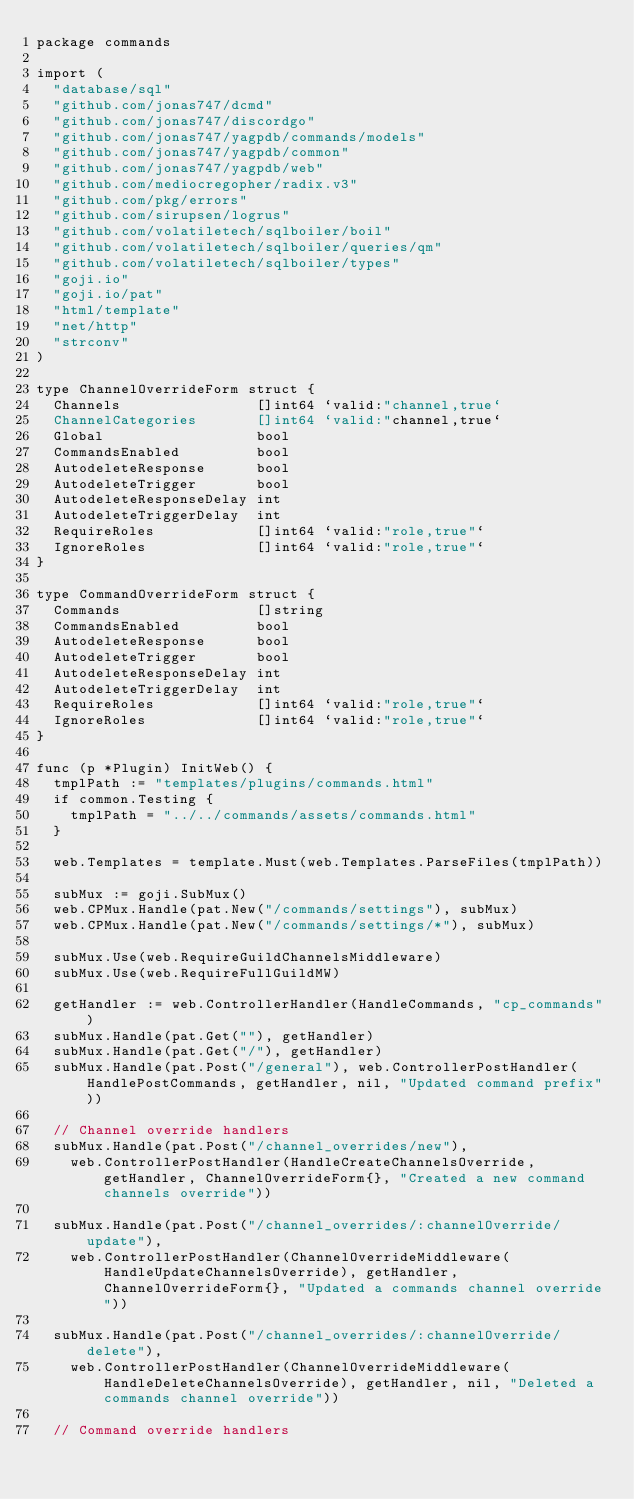Convert code to text. <code><loc_0><loc_0><loc_500><loc_500><_Go_>package commands

import (
	"database/sql"
	"github.com/jonas747/dcmd"
	"github.com/jonas747/discordgo"
	"github.com/jonas747/yagpdb/commands/models"
	"github.com/jonas747/yagpdb/common"
	"github.com/jonas747/yagpdb/web"
	"github.com/mediocregopher/radix.v3"
	"github.com/pkg/errors"
	"github.com/sirupsen/logrus"
	"github.com/volatiletech/sqlboiler/boil"
	"github.com/volatiletech/sqlboiler/queries/qm"
	"github.com/volatiletech/sqlboiler/types"
	"goji.io"
	"goji.io/pat"
	"html/template"
	"net/http"
	"strconv"
)

type ChannelOverrideForm struct {
	Channels                []int64 `valid:"channel,true`
	ChannelCategories       []int64 `valid:"channel,true`
	Global                  bool
	CommandsEnabled         bool
	AutodeleteResponse      bool
	AutodeleteTrigger       bool
	AutodeleteResponseDelay int
	AutodeleteTriggerDelay  int
	RequireRoles            []int64 `valid:"role,true"`
	IgnoreRoles             []int64 `valid:"role,true"`
}

type CommandOverrideForm struct {
	Commands                []string
	CommandsEnabled         bool
	AutodeleteResponse      bool
	AutodeleteTrigger       bool
	AutodeleteResponseDelay int
	AutodeleteTriggerDelay  int
	RequireRoles            []int64 `valid:"role,true"`
	IgnoreRoles             []int64 `valid:"role,true"`
}

func (p *Plugin) InitWeb() {
	tmplPath := "templates/plugins/commands.html"
	if common.Testing {
		tmplPath = "../../commands/assets/commands.html"
	}

	web.Templates = template.Must(web.Templates.ParseFiles(tmplPath))

	subMux := goji.SubMux()
	web.CPMux.Handle(pat.New("/commands/settings"), subMux)
	web.CPMux.Handle(pat.New("/commands/settings/*"), subMux)

	subMux.Use(web.RequireGuildChannelsMiddleware)
	subMux.Use(web.RequireFullGuildMW)

	getHandler := web.ControllerHandler(HandleCommands, "cp_commands")
	subMux.Handle(pat.Get(""), getHandler)
	subMux.Handle(pat.Get("/"), getHandler)
	subMux.Handle(pat.Post("/general"), web.ControllerPostHandler(HandlePostCommands, getHandler, nil, "Updated command prefix"))

	// Channel override handlers
	subMux.Handle(pat.Post("/channel_overrides/new"),
		web.ControllerPostHandler(HandleCreateChannelsOverride, getHandler, ChannelOverrideForm{}, "Created a new command channels override"))

	subMux.Handle(pat.Post("/channel_overrides/:channelOverride/update"),
		web.ControllerPostHandler(ChannelOverrideMiddleware(HandleUpdateChannelsOverride), getHandler, ChannelOverrideForm{}, "Updated a commands channel override"))

	subMux.Handle(pat.Post("/channel_overrides/:channelOverride/delete"),
		web.ControllerPostHandler(ChannelOverrideMiddleware(HandleDeleteChannelsOverride), getHandler, nil, "Deleted a commands channel override"))

	// Command override handlers</code> 